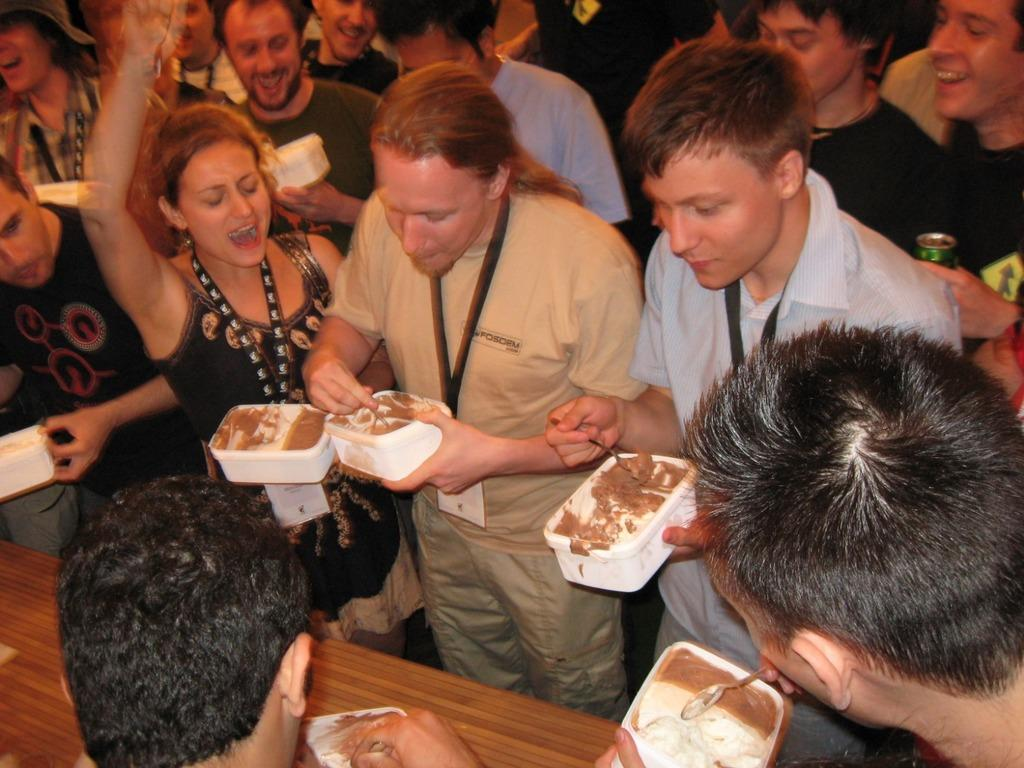What are the persons in the image doing? The persons in the image are standing near a table and holding a box and a spoon. What is inside the box they are holding? The box contains food items. Can you describe the objects the persons are holding? They are holding a box and a spoon. What type of shoes are the persons wearing in the image? There is no information about shoes in the image, as the focus is on the persons holding a box and a spoon. 